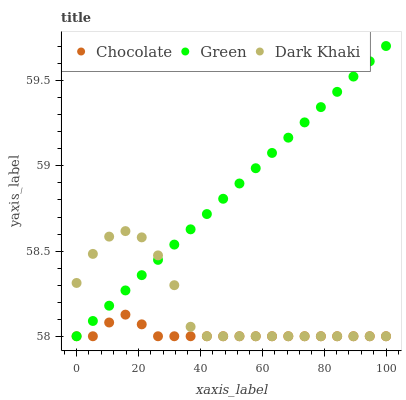Does Chocolate have the minimum area under the curve?
Answer yes or no. Yes. Does Green have the maximum area under the curve?
Answer yes or no. Yes. Does Green have the minimum area under the curve?
Answer yes or no. No. Does Chocolate have the maximum area under the curve?
Answer yes or no. No. Is Green the smoothest?
Answer yes or no. Yes. Is Dark Khaki the roughest?
Answer yes or no. Yes. Is Chocolate the smoothest?
Answer yes or no. No. Is Chocolate the roughest?
Answer yes or no. No. Does Dark Khaki have the lowest value?
Answer yes or no. Yes. Does Green have the highest value?
Answer yes or no. Yes. Does Chocolate have the highest value?
Answer yes or no. No. Does Green intersect Chocolate?
Answer yes or no. Yes. Is Green less than Chocolate?
Answer yes or no. No. Is Green greater than Chocolate?
Answer yes or no. No. 